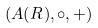<formula> <loc_0><loc_0><loc_500><loc_500>( A ( R ) , \circ , + )</formula> 